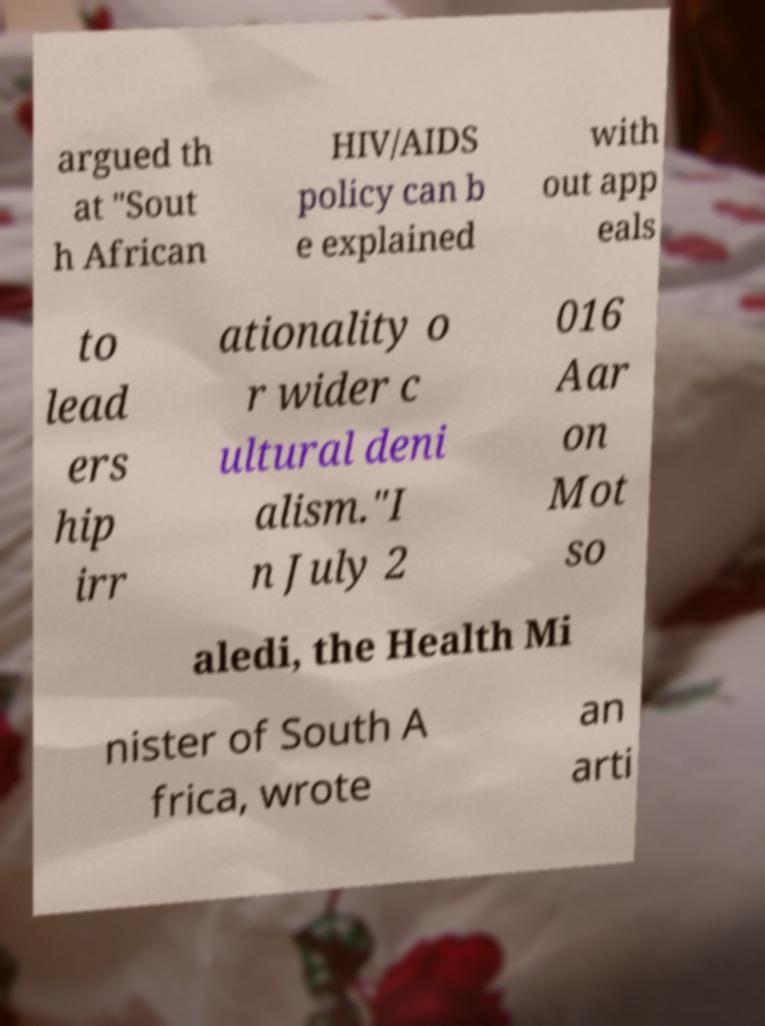Can you accurately transcribe the text from the provided image for me? argued th at "Sout h African HIV/AIDS policy can b e explained with out app eals to lead ers hip irr ationality o r wider c ultural deni alism."I n July 2 016 Aar on Mot so aledi, the Health Mi nister of South A frica, wrote an arti 